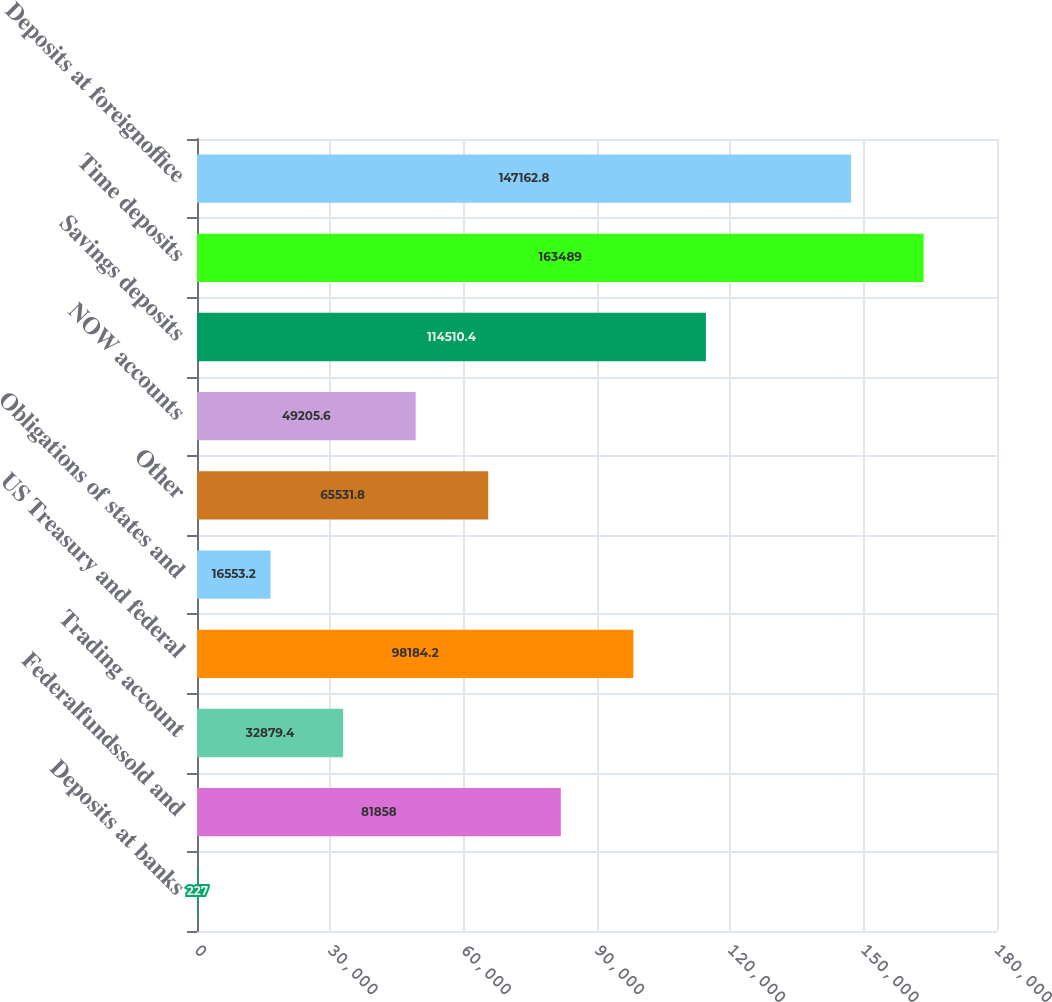<chart> <loc_0><loc_0><loc_500><loc_500><bar_chart><fcel>Deposits at banks<fcel>Federalfundssold and<fcel>Trading account<fcel>US Treasury and federal<fcel>Obligations of states and<fcel>Other<fcel>NOW accounts<fcel>Savings deposits<fcel>Time deposits<fcel>Deposits at foreignoffice<nl><fcel>227<fcel>81858<fcel>32879.4<fcel>98184.2<fcel>16553.2<fcel>65531.8<fcel>49205.6<fcel>114510<fcel>163489<fcel>147163<nl></chart> 